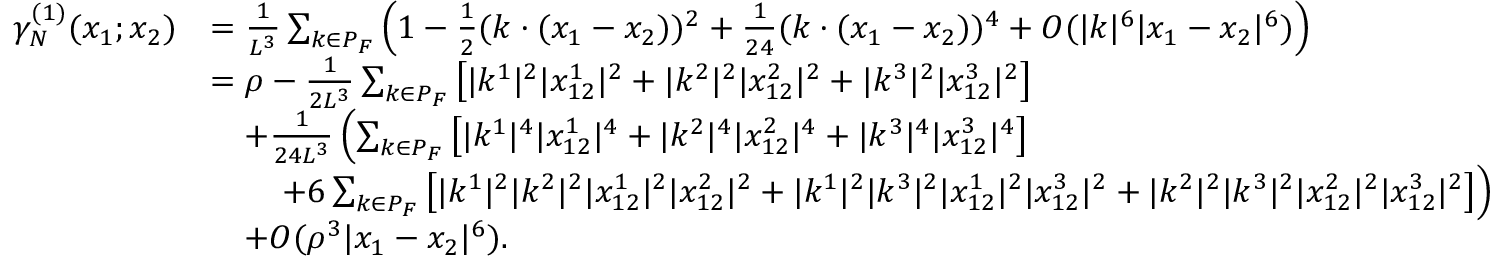<formula> <loc_0><loc_0><loc_500><loc_500>\begin{array} { r l } { \gamma _ { N } ^ { ( 1 ) } ( x _ { 1 } ; x _ { 2 } ) } & { = \frac { 1 } { L ^ { 3 } } \sum _ { k \in P _ { F } } \left ( 1 - \frac { 1 } { 2 } ( k \cdot ( x _ { 1 } - x _ { 2 } ) ) ^ { 2 } + \frac { 1 } { 2 4 } ( k \cdot ( x _ { 1 } - x _ { 2 } ) ) ^ { 4 } + O ( | k | ^ { 6 } | x _ { 1 } - x _ { 2 } | ^ { 6 } ) \right ) } \\ & { = \rho - \frac { 1 } { 2 L ^ { 3 } } \sum _ { k \in P _ { F } } \left [ | k ^ { 1 } | ^ { 2 } | x _ { 1 2 } ^ { 1 } | ^ { 2 } + | k ^ { 2 } | ^ { 2 } | x _ { 1 2 } ^ { 2 } | ^ { 2 } + | k ^ { 3 } | ^ { 2 } | x _ { 1 2 } ^ { 3 } | ^ { 2 } \right ] } \\ & { \quad + \frac { 1 } { 2 4 L ^ { 3 } } \left ( \sum _ { k \in P _ { F } } \left [ | k ^ { 1 } | ^ { 4 } | x _ { 1 2 } ^ { 1 } | ^ { 4 } + | k ^ { 2 } | ^ { 4 } | x _ { 1 2 } ^ { 2 } | ^ { 4 } + | k ^ { 3 } | ^ { 4 } | x _ { 1 2 } ^ { 3 } | ^ { 4 } \right ] } \\ & { \quad + 6 \sum _ { k \in P _ { F } } \left [ | k ^ { 1 } | ^ { 2 } | k ^ { 2 } | ^ { 2 } | x _ { 1 2 } ^ { 1 } | ^ { 2 } | x _ { 1 2 } ^ { 2 } | ^ { 2 } + | k ^ { 1 } | ^ { 2 } | k ^ { 3 } | ^ { 2 } | x _ { 1 2 } ^ { 1 } | ^ { 2 } | x _ { 1 2 } ^ { 3 } | ^ { 2 } + | k ^ { 2 } | ^ { 2 } | k ^ { 3 } | ^ { 2 } | x _ { 1 2 } ^ { 2 } | ^ { 2 } | x _ { 1 2 } ^ { 3 } | ^ { 2 } \right ] \right ) } \\ & { \quad + O ( \rho ^ { 3 } | x _ { 1 } - x _ { 2 } | ^ { 6 } ) . } \end{array}</formula> 